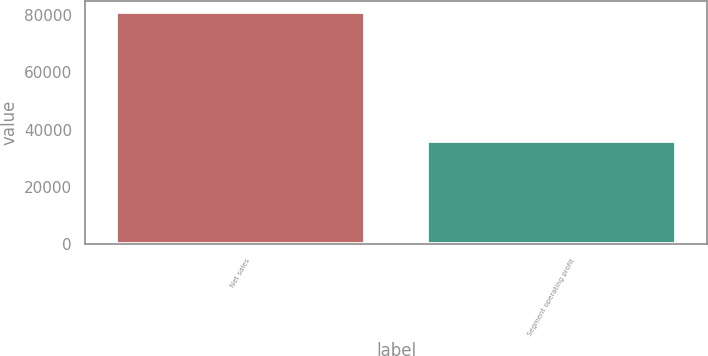Convert chart to OTSL. <chart><loc_0><loc_0><loc_500><loc_500><bar_chart><fcel>Net sales<fcel>Segment operating profit<nl><fcel>80841<fcel>35867<nl></chart> 